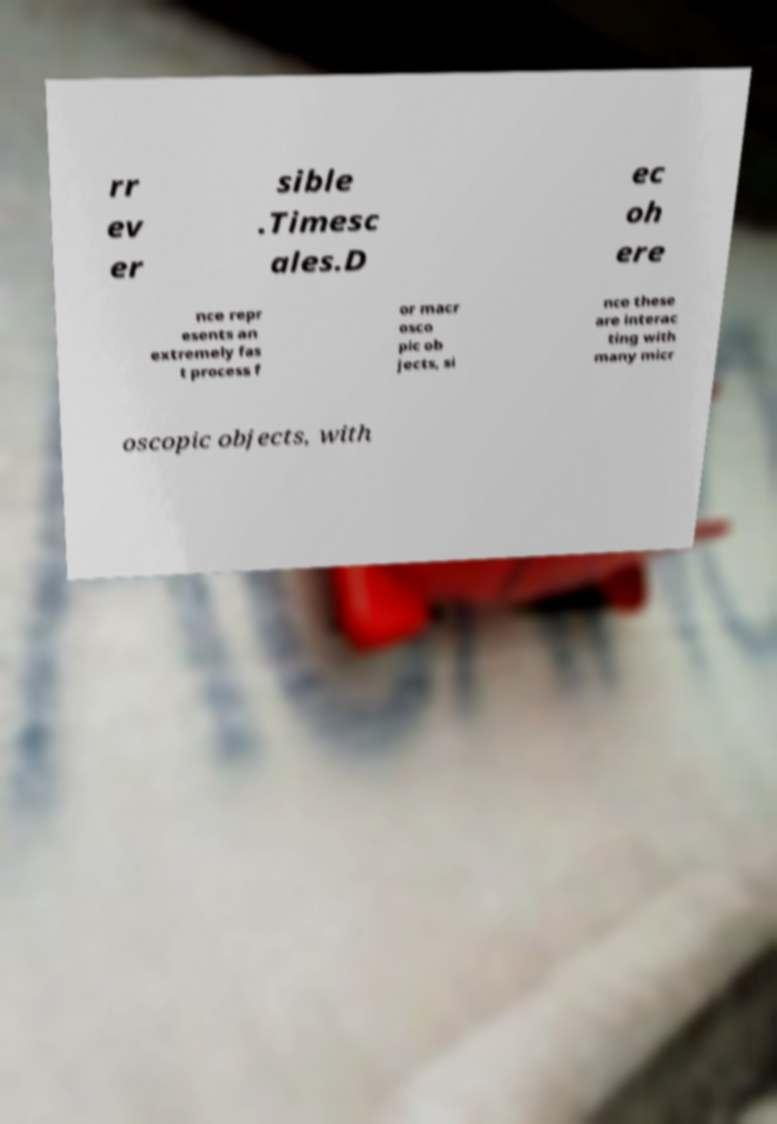There's text embedded in this image that I need extracted. Can you transcribe it verbatim? rr ev er sible .Timesc ales.D ec oh ere nce repr esents an extremely fas t process f or macr osco pic ob jects, si nce these are interac ting with many micr oscopic objects, with 